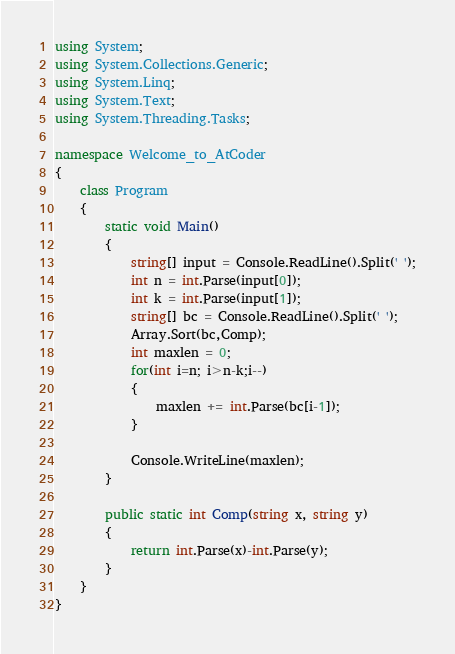<code> <loc_0><loc_0><loc_500><loc_500><_C#_>using System;
using System.Collections.Generic;
using System.Linq;
using System.Text;
using System.Threading.Tasks;

namespace Welcome_to_AtCoder
{
    class Program
    {
        static void Main()
        {
            string[] input = Console.ReadLine().Split(' ');
            int n = int.Parse(input[0]);
            int k = int.Parse(input[1]);
            string[] bc = Console.ReadLine().Split(' ');
            Array.Sort(bc,Comp);
            int maxlen = 0;
            for(int i=n; i>n-k;i--)
            {
                maxlen += int.Parse(bc[i-1]);
            }

            Console.WriteLine(maxlen);
        }

        public static int Comp(string x, string y)
        {
            return int.Parse(x)-int.Parse(y);
        }
    }
}</code> 